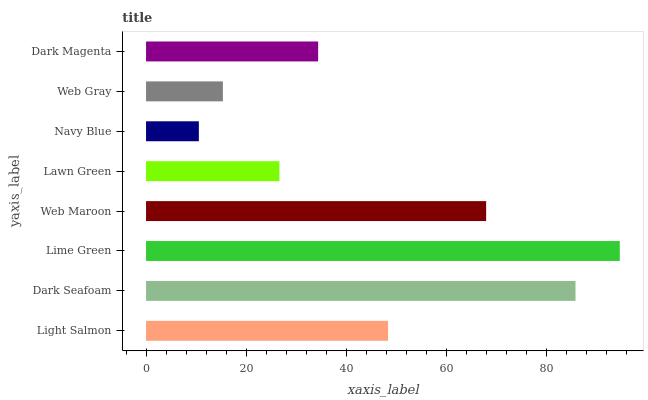Is Navy Blue the minimum?
Answer yes or no. Yes. Is Lime Green the maximum?
Answer yes or no. Yes. Is Dark Seafoam the minimum?
Answer yes or no. No. Is Dark Seafoam the maximum?
Answer yes or no. No. Is Dark Seafoam greater than Light Salmon?
Answer yes or no. Yes. Is Light Salmon less than Dark Seafoam?
Answer yes or no. Yes. Is Light Salmon greater than Dark Seafoam?
Answer yes or no. No. Is Dark Seafoam less than Light Salmon?
Answer yes or no. No. Is Light Salmon the high median?
Answer yes or no. Yes. Is Dark Magenta the low median?
Answer yes or no. Yes. Is Lime Green the high median?
Answer yes or no. No. Is Navy Blue the low median?
Answer yes or no. No. 